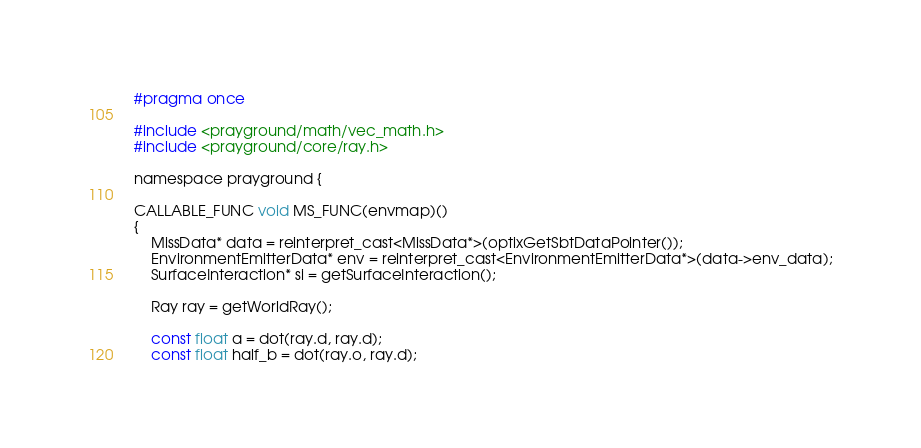<code> <loc_0><loc_0><loc_500><loc_500><_Cuda_>#pragma once

#include <prayground/math/vec_math.h>
#include <prayground/core/ray.h>

namespace prayground {

CALLABLE_FUNC void MS_FUNC(envmap)()
{
    MissData* data = reinterpret_cast<MissData*>(optixGetSbtDataPointer());
    EnvironmentEmitterData* env = reinterpret_cast<EnvironmentEmitterData*>(data->env_data);
    SurfaceInteraction* si = getSurfaceInteraction();

    Ray ray = getWorldRay();

    const float a = dot(ray.d, ray.d);
    const float half_b = dot(ray.o, ray.d);</code> 